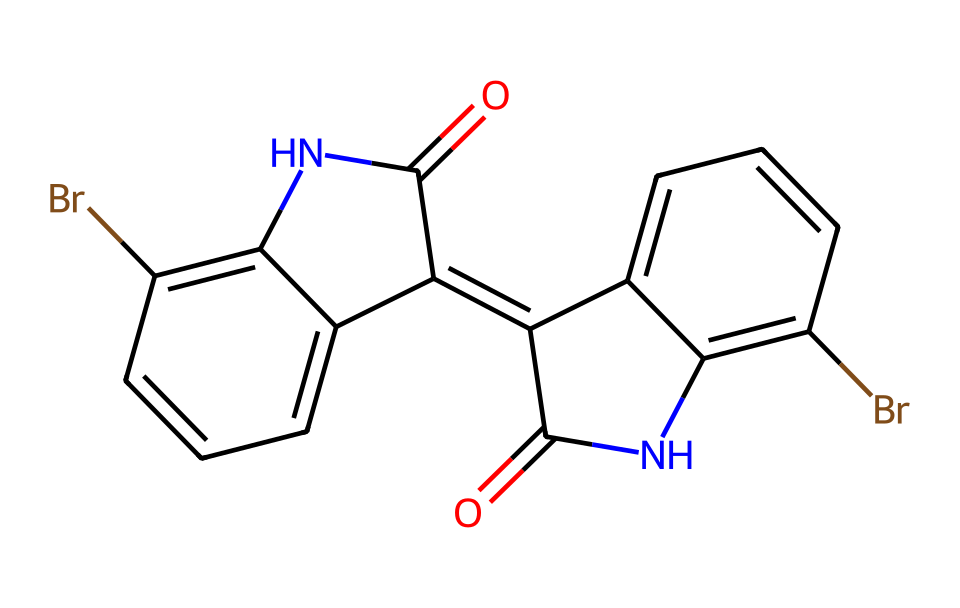What is the molecular formula for Tyrian purple? To determine the molecular formula, we identify the types and counts of atoms from the SMILES representation. The molecule consists of carbon (C), hydrogen (H), nitrogen (N), and bromine (Br). Counting the atoms gives us: 20 carbons, 12 hydrogens, 4 nitrogens, and 2 bromines, resulting in the formula C20H12Br2N4O2.
Answer: C20H12Br2N4O2 How many nitrogen atoms are present in the chemical structure? By examining the SMILES representation, we note the presence of the nitrogen symbols 'N'. Counting them reveals that there are 4 nitrogen atoms in total.
Answer: 4 What type of chemical bond is predominantly featured in the dye? The presence of the double bonds in the aromatic rings suggests that the predominant bond type is covalent. These bonds hold the atoms together in the structure of the dye.
Answer: covalent Is Tyrian purple a natural or synthetic dye? Historical usage and research indicate that Tyrian purple originates from natural sources, specifically from the mucus of certain sea snails.
Answer: natural What characteristic property makes Tyrian purple valuable and prestigious? The dye's ability to produce a rich, vibrant purple color during antiquity made it highly sought after, representing luxury and status in ancient cultures.
Answer: vibrant purple color What is the significance of the bromine atoms in Tyrian purple? The bromine atoms contribute to the stability of the dye and affect its solubility, color intensity, and resistance to fading, making Tyrian purple more desirable for dyeing textiles.
Answer: stability and color intensity How many rings are present in the structure of Tyrian purple? Upon inspection of the SMILES structure, it is observed that there are two interconnected aromatic rings, which are a hallmark of many natural dyes, including Tyrian purple.
Answer: 2 